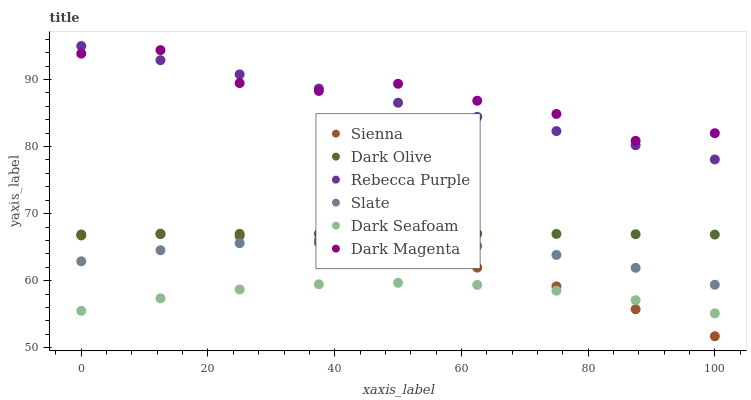Does Dark Seafoam have the minimum area under the curve?
Answer yes or no. Yes. Does Dark Magenta have the maximum area under the curve?
Answer yes or no. Yes. Does Slate have the minimum area under the curve?
Answer yes or no. No. Does Slate have the maximum area under the curve?
Answer yes or no. No. Is Rebecca Purple the smoothest?
Answer yes or no. Yes. Is Dark Magenta the roughest?
Answer yes or no. Yes. Is Slate the smoothest?
Answer yes or no. No. Is Slate the roughest?
Answer yes or no. No. Does Sienna have the lowest value?
Answer yes or no. Yes. Does Slate have the lowest value?
Answer yes or no. No. Does Rebecca Purple have the highest value?
Answer yes or no. Yes. Does Slate have the highest value?
Answer yes or no. No. Is Dark Seafoam less than Dark Olive?
Answer yes or no. Yes. Is Rebecca Purple greater than Dark Seafoam?
Answer yes or no. Yes. Does Rebecca Purple intersect Dark Magenta?
Answer yes or no. Yes. Is Rebecca Purple less than Dark Magenta?
Answer yes or no. No. Is Rebecca Purple greater than Dark Magenta?
Answer yes or no. No. Does Dark Seafoam intersect Dark Olive?
Answer yes or no. No. 